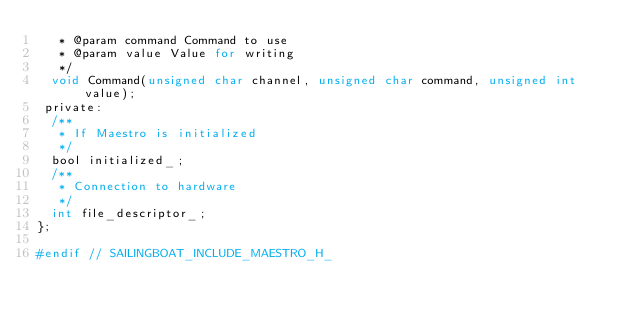Convert code to text. <code><loc_0><loc_0><loc_500><loc_500><_C_>   * @param command Command to use
   * @param value Value for writing
   */
  void Command(unsigned char channel, unsigned char command, unsigned int value);
 private:
  /**
   * If Maestro is initialized
   */
  bool initialized_;
  /**
   * Connection to hardware
   */
  int file_descriptor_;
};

#endif // SAILINGBOAT_INCLUDE_MAESTRO_H_
</code> 